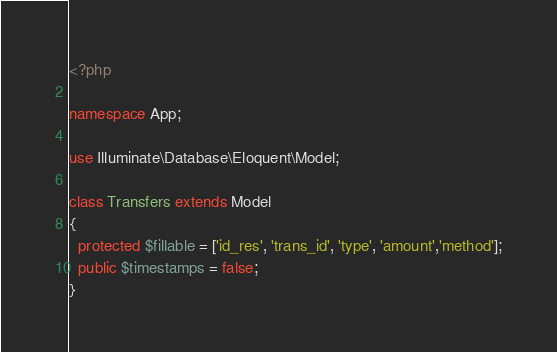<code> <loc_0><loc_0><loc_500><loc_500><_PHP_><?php

namespace App;

use Illuminate\Database\Eloquent\Model;

class Transfers extends Model
{
  protected $fillable = ['id_res', 'trans_id', 'type', 'amount','method'];
  public $timestamps = false;
}
</code> 